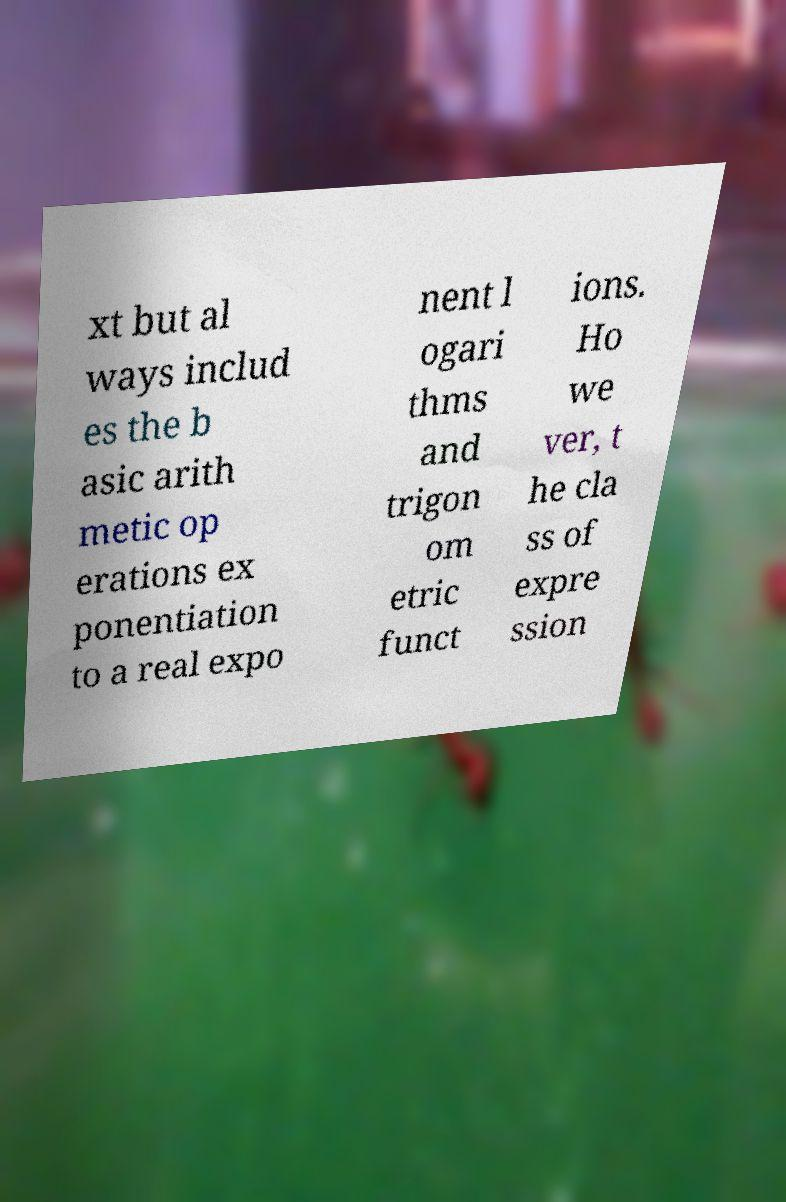I need the written content from this picture converted into text. Can you do that? xt but al ways includ es the b asic arith metic op erations ex ponentiation to a real expo nent l ogari thms and trigon om etric funct ions. Ho we ver, t he cla ss of expre ssion 